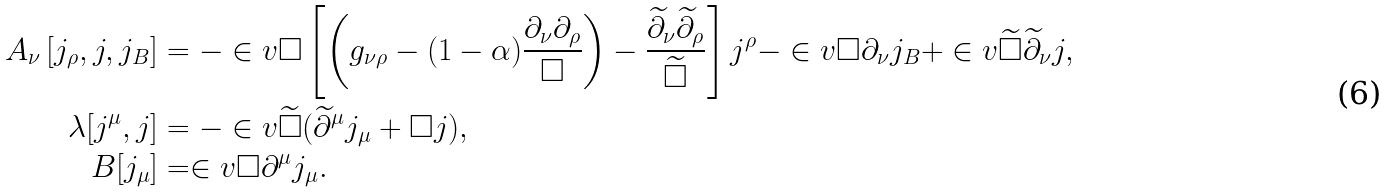Convert formula to latex. <formula><loc_0><loc_0><loc_500><loc_500>A _ { \nu } \left [ j _ { \rho } , j , j _ { B } \right ] & = - \in v \square \left [ \left ( g _ { \nu \rho } - ( 1 - \alpha ) \frac { \partial _ { \nu } \partial _ { \rho } } { \square } \right ) - \frac { \widetilde { \partial } _ { \nu } \widetilde { \partial } _ { \rho } } { \widetilde { \square } } \right ] j ^ { \rho } - \in v \square \partial _ { \nu } j _ { B } + \in v { \widetilde { \square } } \widetilde { \partial } _ { \nu } j , \\ \lambda [ j ^ { \mu } , j ] & = - \in v { \widetilde { \square } } ( \widetilde { \partial } ^ { \mu } j _ { \mu } + \square j ) , \\ B [ j _ { \mu } ] & = \in v \square \partial ^ { \mu } j _ { \mu } .</formula> 